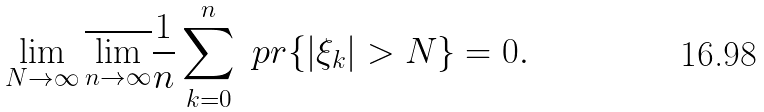<formula> <loc_0><loc_0><loc_500><loc_500>\lim _ { N \rightarrow \infty } \overline { \lim _ { n \rightarrow \infty } } \frac { 1 } { n } \sum _ { k = 0 } ^ { n } \ p r \{ | \xi _ { k } | > N \} = 0 .</formula> 